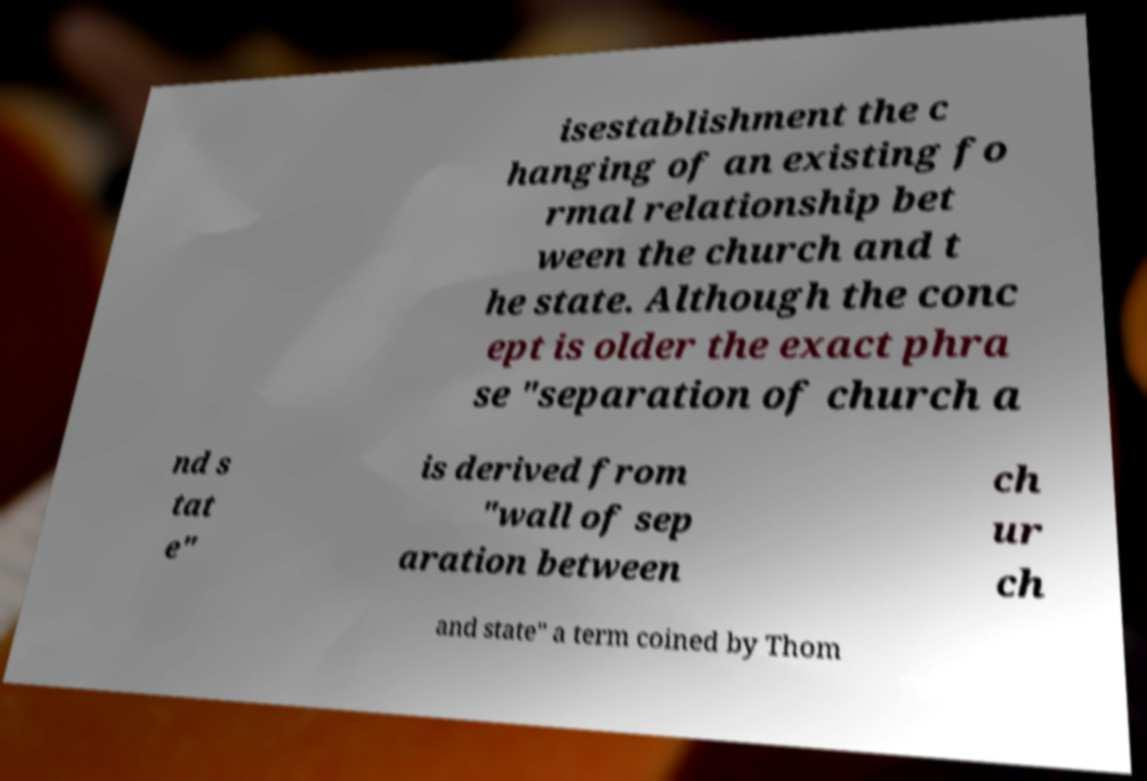There's text embedded in this image that I need extracted. Can you transcribe it verbatim? isestablishment the c hanging of an existing fo rmal relationship bet ween the church and t he state. Although the conc ept is older the exact phra se "separation of church a nd s tat e" is derived from "wall of sep aration between ch ur ch and state" a term coined by Thom 